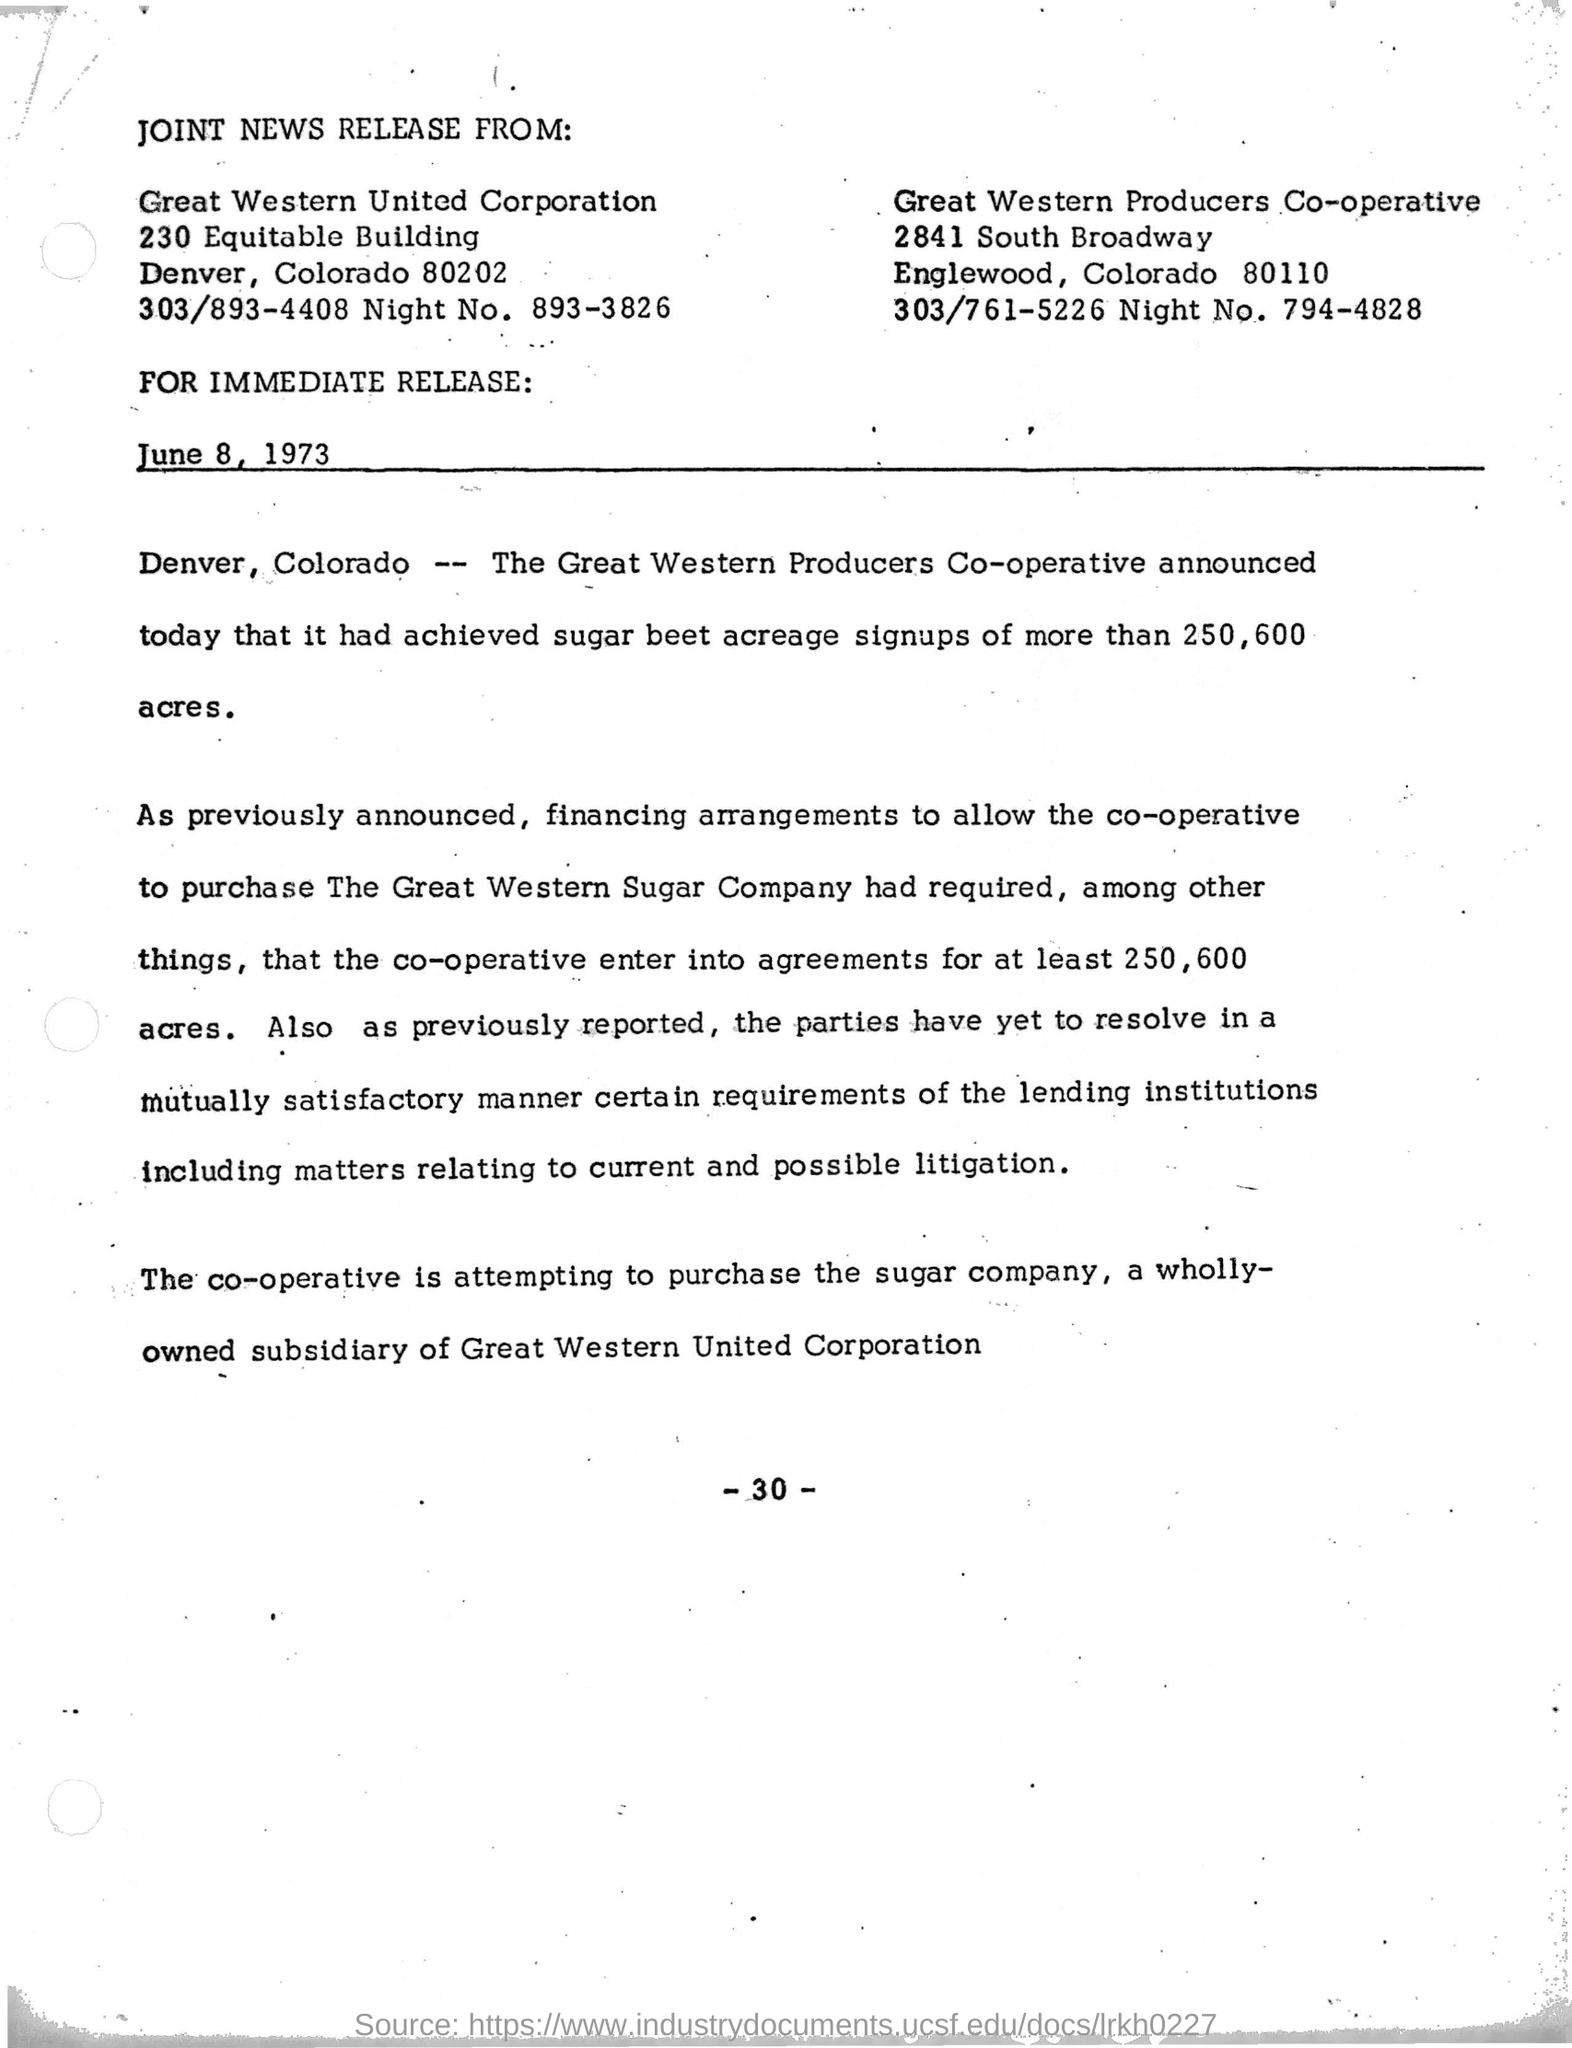Date mentioned in the text?
Your response must be concise. June 8, 1973. 